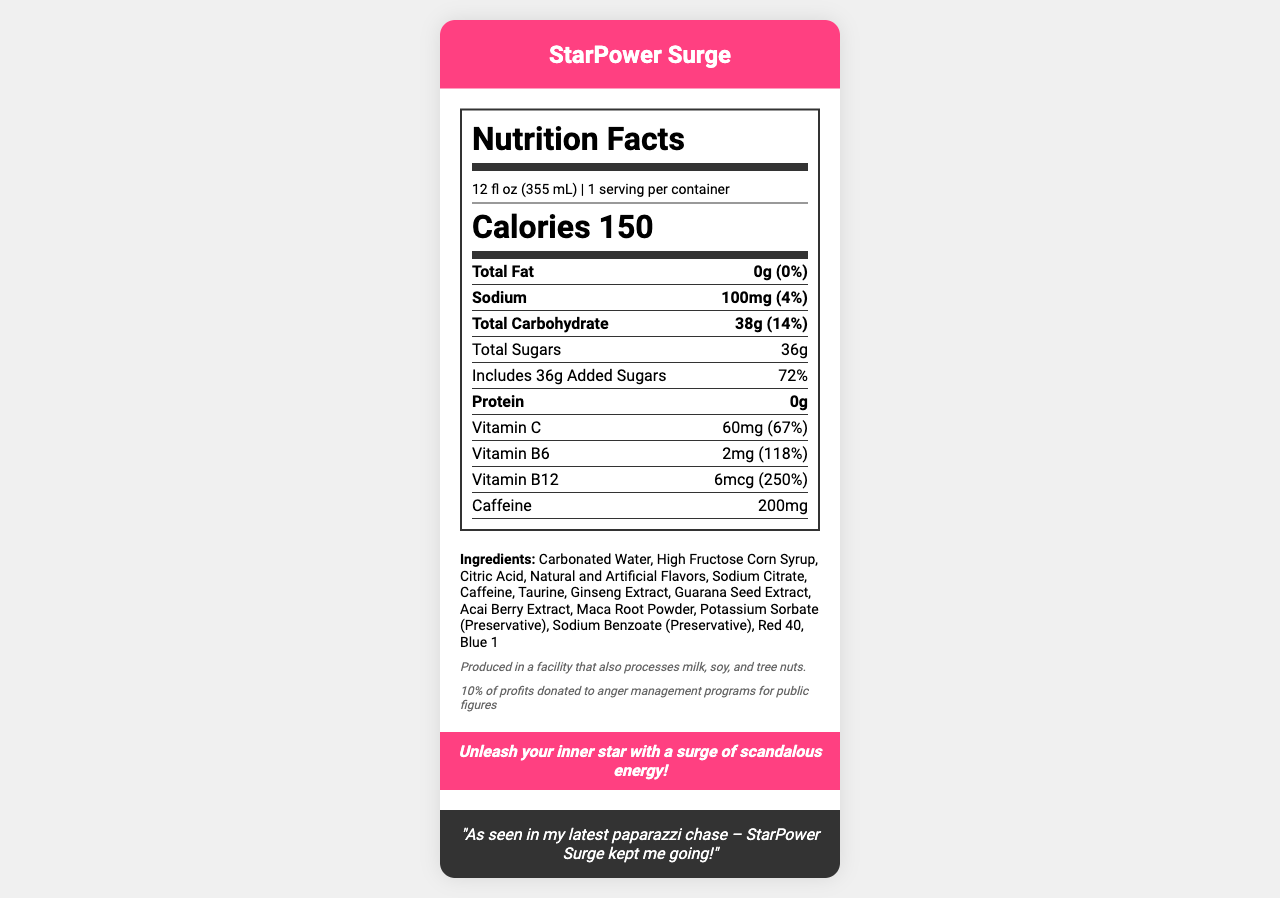what is the serving size? The serving size is listed at the top of the nutrition facts label.
Answer: 12 fl oz (355 mL) how many calories are in one serving? The calories per serving are prominently displayed as "Calories 150".
Answer: 150 how much total carbohydrate is in the drink? The amount of total carbohydrate is listed in the nutrients section as "Total Carbohydrate 38g".
Answer: 38g what percentage of the daily value does the vitamin B12 content of the drink provide? The percentage of daily value for vitamin B12 is listed as 250%.
Answer: 250% which ingredient is used both as a preservative and listed in the ingredients list? The ingredient section lists "Potassium Sorbate (Preservative)" indicating it is used as a preservative.
Answer: Potassium Sorbate how much sodium is in the drink? A. 50mg B. 100mg C. 150mg D. 200mg The sodium content is listed as 100mg.
Answer: B. 100mg what percentage of the daily value of added sugars does the drink contain? The daily value percentage for added sugars is given as 72%.
Answer: 72% which exotic ingredients are included in the drink? A. Acai Berry Extract B. Ginseng Extract C. Guarana Seed Extract D. All of the above The exotic ingredients listed in the document include Acai Berry Extract, Ginseng Extract, and Guarana Seed Extract.
Answer: D. All of the above is this drink produced in a facility that processes allergens? The allergen information states "Produced in a facility that also processes milk, soy, and tree nuts."
Answer: Yes what is the main marketing slogan of the drink? The marketing tagline is listed toward the bottom of the document.
Answer: Unleash your inner star with a surge of scandalous energy! explain the caffeine content in the drink The caffeine content is specifically listed as 200mg in the nutrient section.
Answer: The drink contains 200mg of caffeine. where is the total fat content of the drink listed? The total fat content is indicated as "0g (0%)" in the nutrient section.
Answer: It is listed in the nutrient section as "Total Fat 0g (0%)". who is the celebrity endorsing this drink? The celebrity endorsement quote attributes the energy during a paparazzi chase to StarPower Surge.
Answer: As seen in my latest paparazzi chase – StarPower Surge kept me going! how many servings are in one container of the drink? The number of servings per container is listed as 1.
Answer: 1 serving summarize the nutrition facts for the "StarPower Surge" energy drink. This summary encompasses the primary details and highlights of the StarPower Surge energy drink provided in the document.
Answer: StarPower Surge energy drink has a serving size of 12 fl oz (355 mL) with 1 serving per container and 150 calories. It contains 38g of carbohydrates, including 36g of sugar (72% of daily value), 0g of fat, 100mg of sodium (4% of daily value), and 0g of protein. It also includes significant amounts of Vitamin C, Vitamin B6, and Vitamin B12 along with 200mg of caffeine, 1000mg of taurine, and various exotic ingredients like Ginseng Extract, Guarana Seed Extract, Acai Berry Extract, and Maca Root Powder. The drink is produced in a facility that processes allergens and donates 10% of profits to anger management programs for public figures. The marketing tagline is "Unleash your inner star with a surge of scandalous energy!" and it is endorsed for providing energy during paparazzi chases. what is the total cost of producing this drink? The document does not provide any cost or pricing information, so this cannot be determined.
Answer: Not enough information 